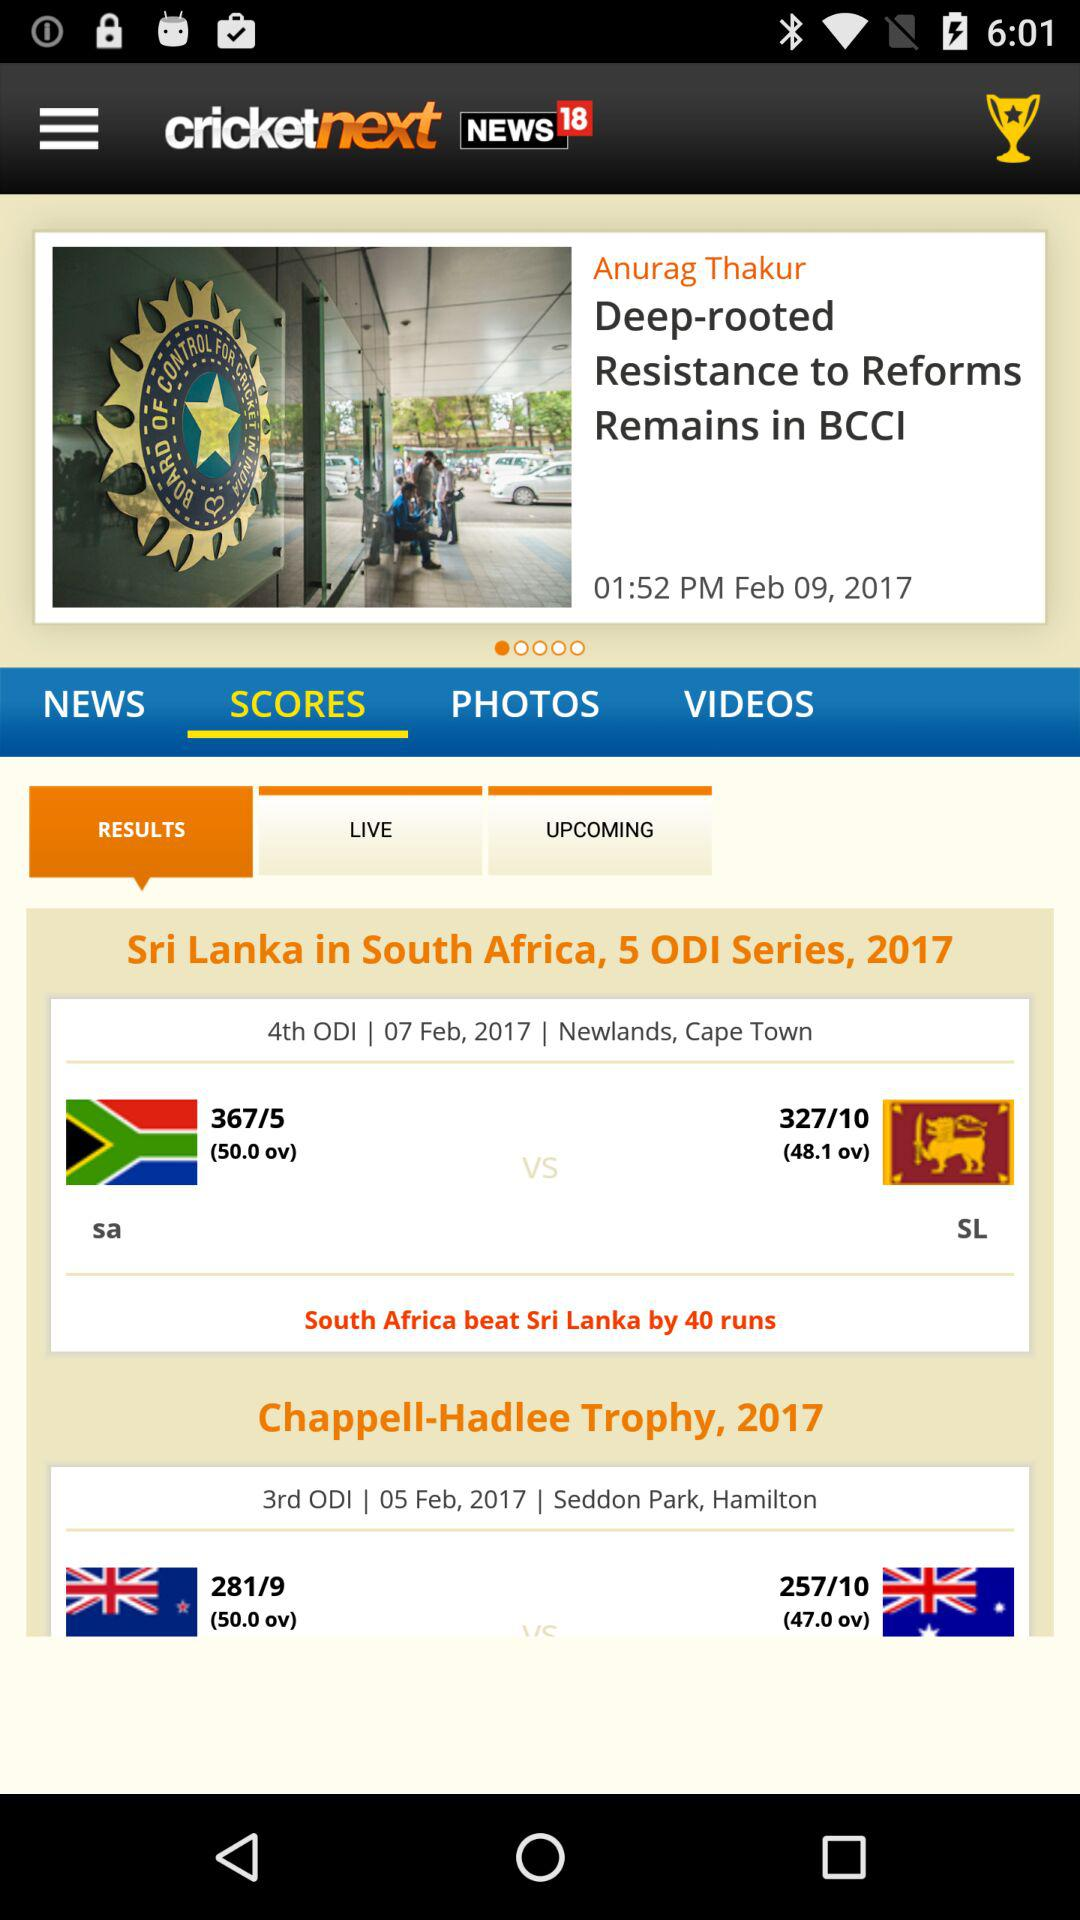What is the location for the 3rd ODI match? The location for the 3rd ODI match is "Seddon Park" in Hamilton. 